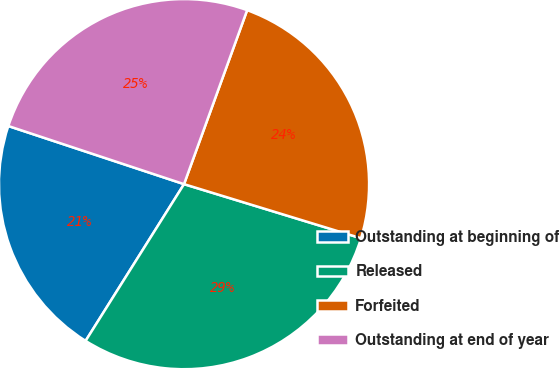Convert chart. <chart><loc_0><loc_0><loc_500><loc_500><pie_chart><fcel>Outstanding at beginning of<fcel>Released<fcel>Forfeited<fcel>Outstanding at end of year<nl><fcel>21.16%<fcel>29.2%<fcel>24.18%<fcel>25.45%<nl></chart> 